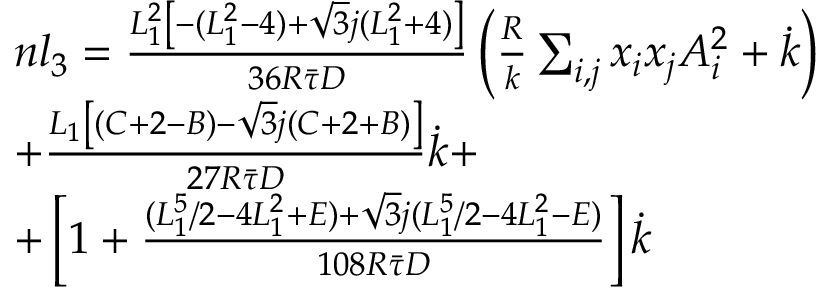Convert formula to latex. <formula><loc_0><loc_0><loc_500><loc_500>\begin{array} { r l } & { n l _ { 3 } = \frac { L _ { 1 } ^ { 2 } \left [ - ( L _ { 1 } ^ { 2 } - 4 ) + \sqrt { 3 } j ( L _ { 1 } ^ { 2 } + 4 ) \right ] } { 3 6 R \bar { \tau } D } \left ( \frac { R } { k } \sum _ { i , j } x _ { i } x _ { j } A _ { i } ^ { 2 } + \dot { k } \right ) } \\ & { + \frac { L _ { 1 } \left [ ( C + 2 - B ) - \sqrt { 3 } j ( C + 2 + B ) \right ] } { 2 7 R \bar { \tau } D } \dot { k } + } \\ & { + \left [ 1 + \frac { ( L _ { 1 } ^ { 5 } / 2 - 4 L _ { 1 } ^ { 2 } + E ) + \sqrt { 3 } j ( L _ { 1 } ^ { 5 } / 2 - 4 L _ { 1 } ^ { 2 } - E ) } { 1 0 8 R \bar { \tau } D } \right ] \dot { k } } \end{array}</formula> 